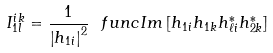Convert formula to latex. <formula><loc_0><loc_0><loc_500><loc_500>I _ { 1 l } ^ { i k } = \frac { 1 } { \left | h _ { 1 i } \right | ^ { 2 } } \ f u n c { I m } \left [ h _ { 1 i } h _ { 1 k } h _ { \ell i } ^ { * } h _ { 2 k } ^ { * } \right ]</formula> 